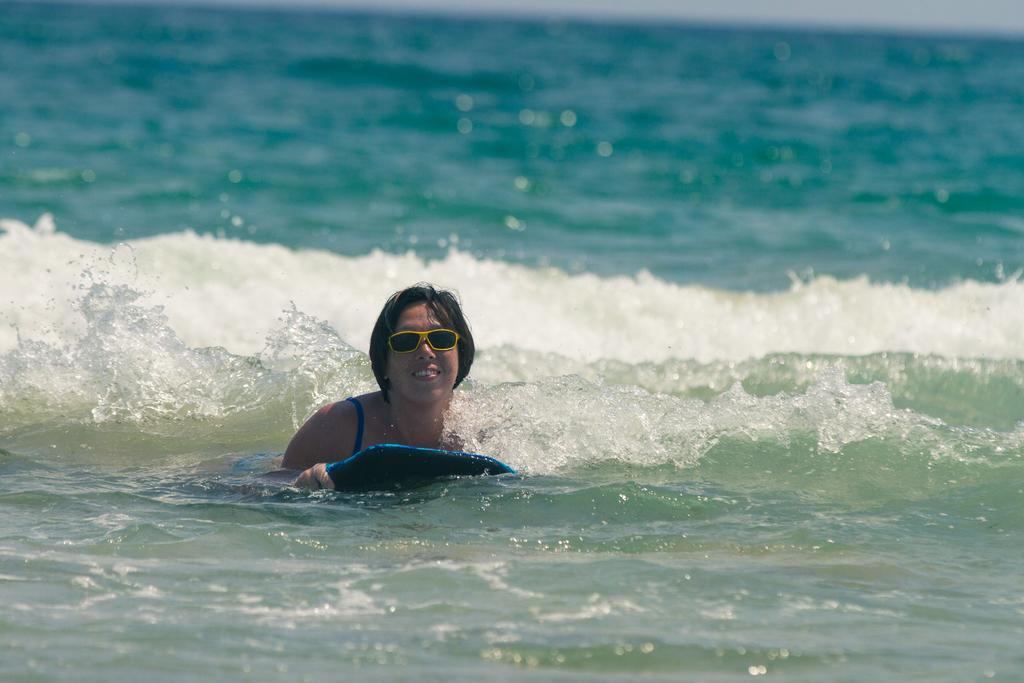Who is present in the image? There is a woman in the image. What is the woman wearing? The woman is wearing glasses. What is the woman doing in the image? The woman is floating in the water. How is the woman floating in the water? The woman is using an object to float. What can be observed about the background of the image? The background of the image is blurred. What type of map can be seen hanging on the wall in the image? There is no map or wall present in the image; it features a woman floating in the water. What color is the orange that the woman is holding in the image? There is no orange present in the image; the woman is floating in the water and wearing glasses. 